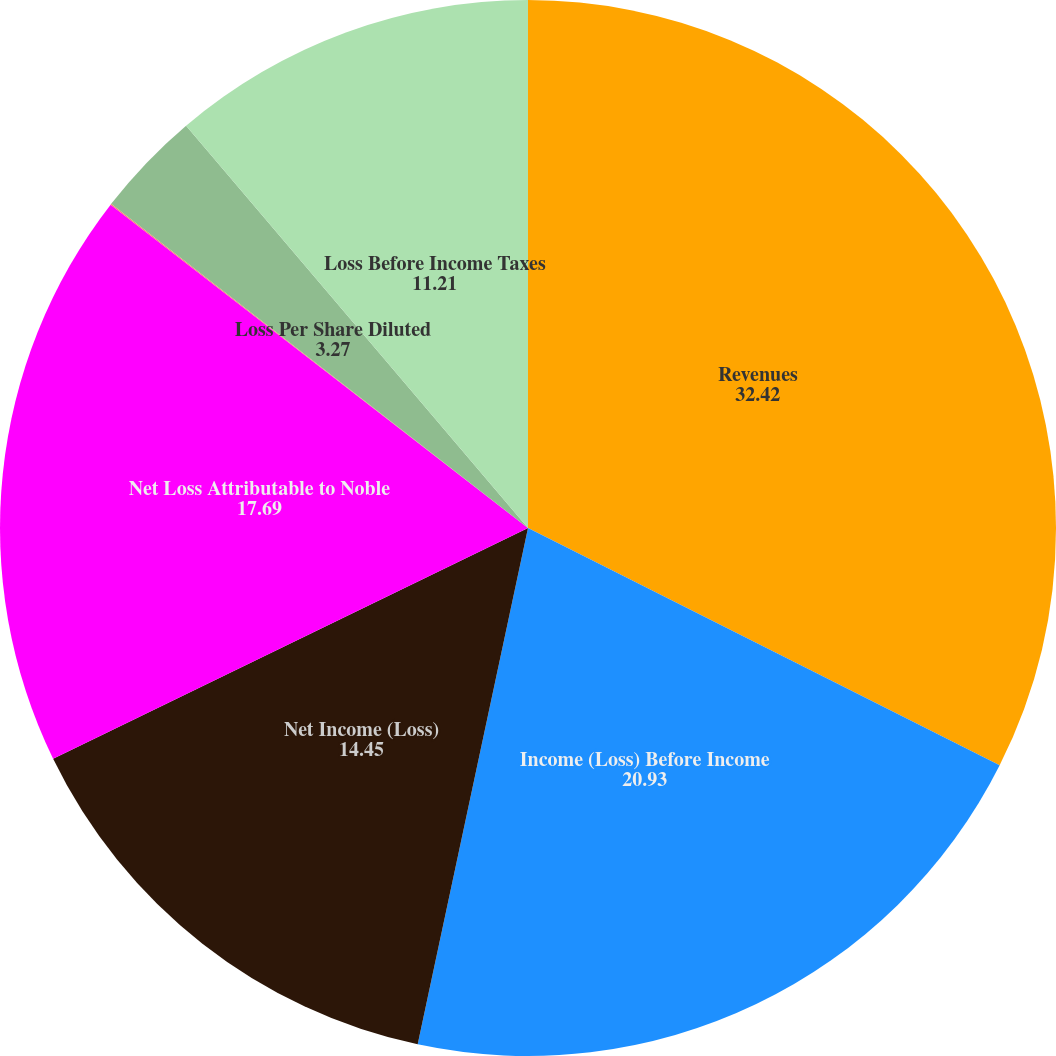Convert chart to OTSL. <chart><loc_0><loc_0><loc_500><loc_500><pie_chart><fcel>Revenues<fcel>Income (Loss) Before Income<fcel>Net Income (Loss)<fcel>Net Loss Attributable to Noble<fcel>Loss Per Share Basic<fcel>Loss Per Share Diluted<fcel>Loss Before Income Taxes<nl><fcel>32.42%<fcel>20.93%<fcel>14.45%<fcel>17.69%<fcel>0.03%<fcel>3.27%<fcel>11.21%<nl></chart> 